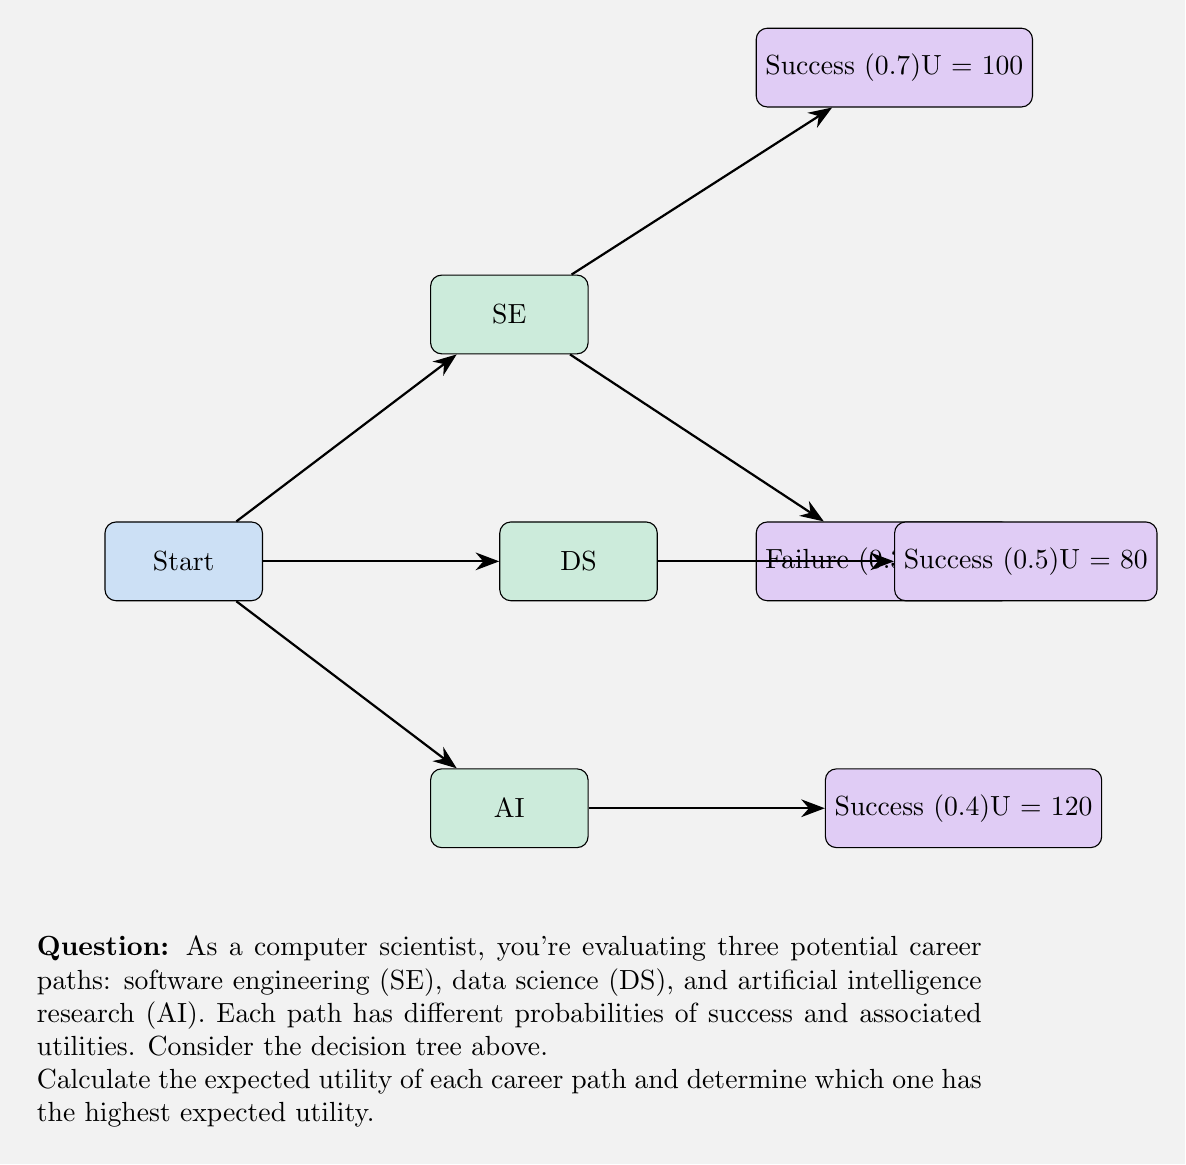Could you help me with this problem? To solve this problem, we need to calculate the expected utility for each career path using the given probabilities and utilities. Let's go through each path step-by-step:

1. Software Engineering (SE):
   - Success probability: 0.7, Utility: 100
   - Failure probability: 0.3, Utility: 20
   Expected Utility (SE) = $0.7 \times 100 + 0.3 \times 20 = 70 + 6 = 76$

2. Data Science (DS):
   - Success probability: 0.5, Utility: 80
   - Failure probability: 0.5, Utility: 0 (assumed, as it's not specified)
   Expected Utility (DS) = $0.5 \times 80 + 0.5 \times 0 = 40 + 0 = 40$

3. Artificial Intelligence Research (AI):
   - Success probability: 0.4, Utility: 120
   - Failure probability: 0.6, Utility: 0 (assumed, as it's not specified)
   Expected Utility (AI) = $0.4 \times 120 + 0.6 \times 0 = 48 + 0 = 48$

Now, we compare the expected utilities:
- SE: 76
- DS: 40
- AI: 48

The career path with the highest expected utility is Software Engineering (SE) with an expected utility of 76.
Answer: Software Engineering, with an expected utility of 76. 